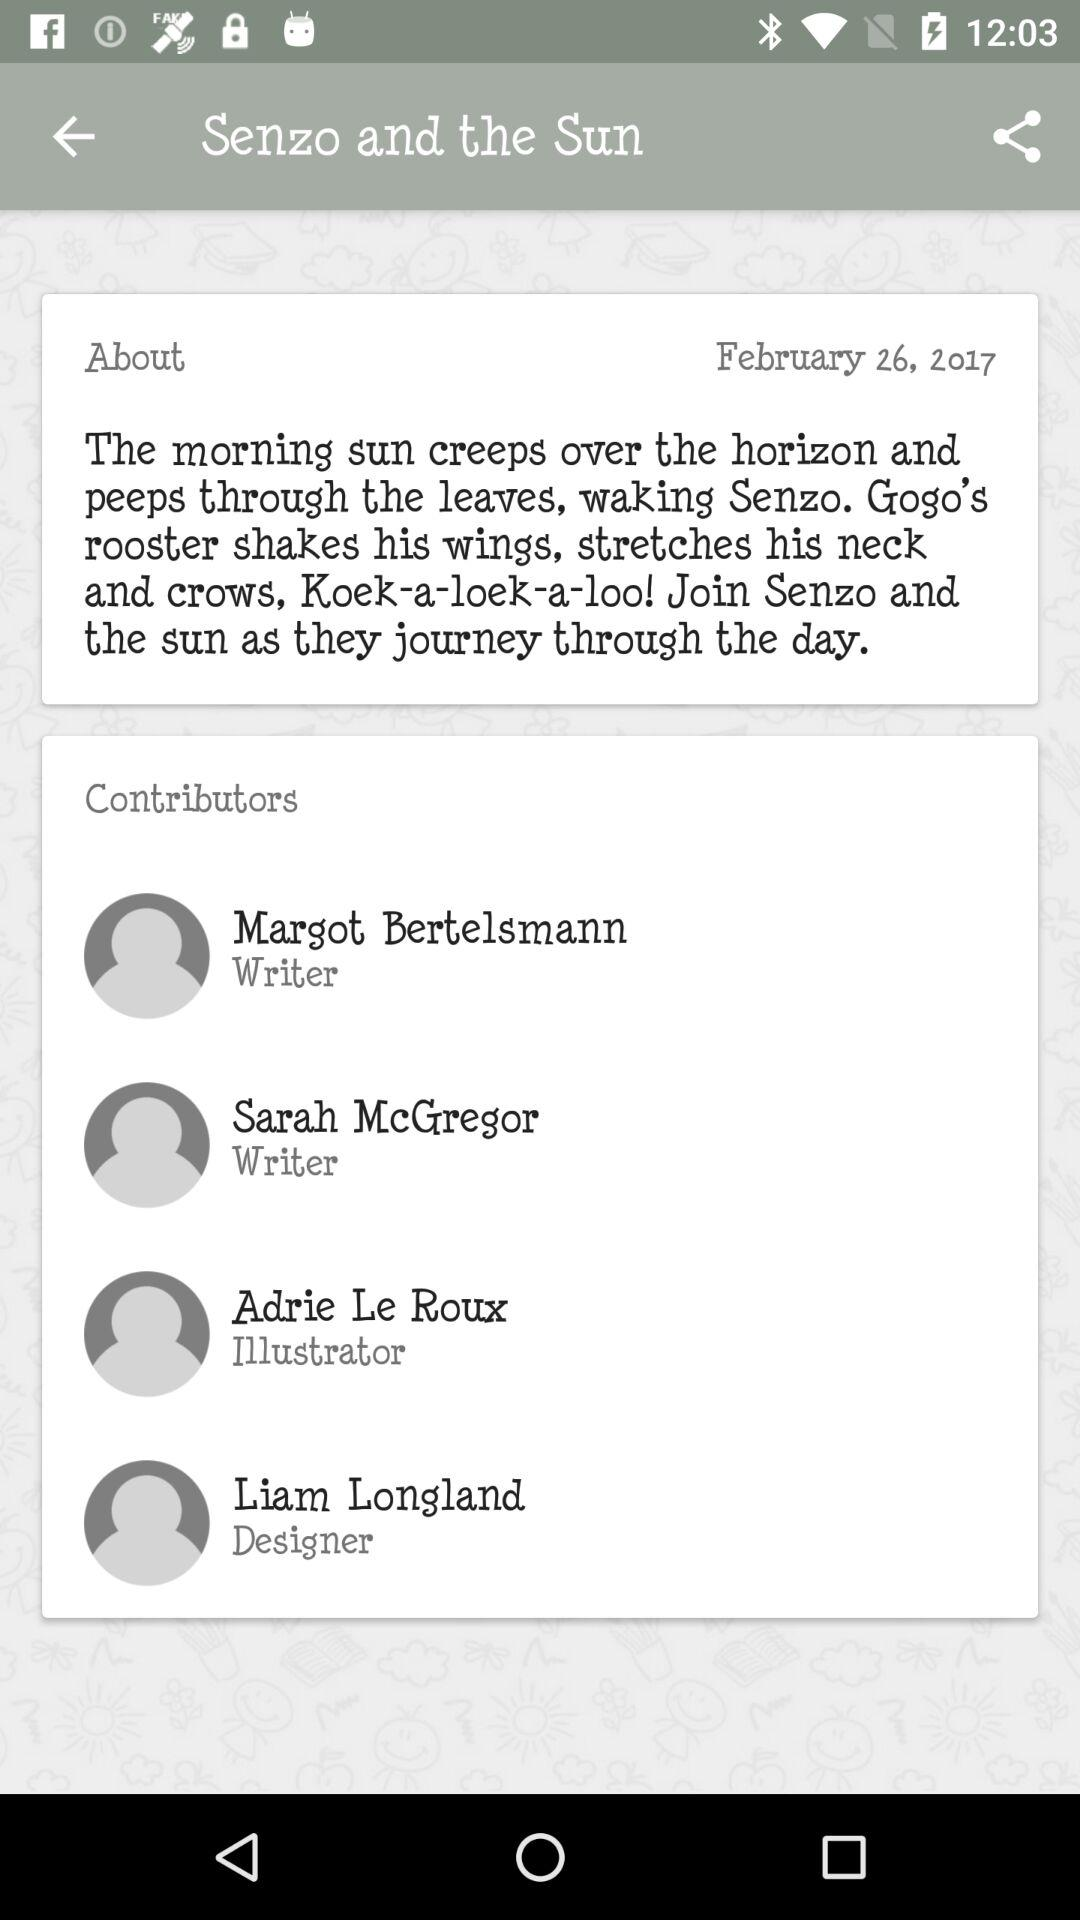Who is the illustrator? The illustrator is Adrie Le Roux. 